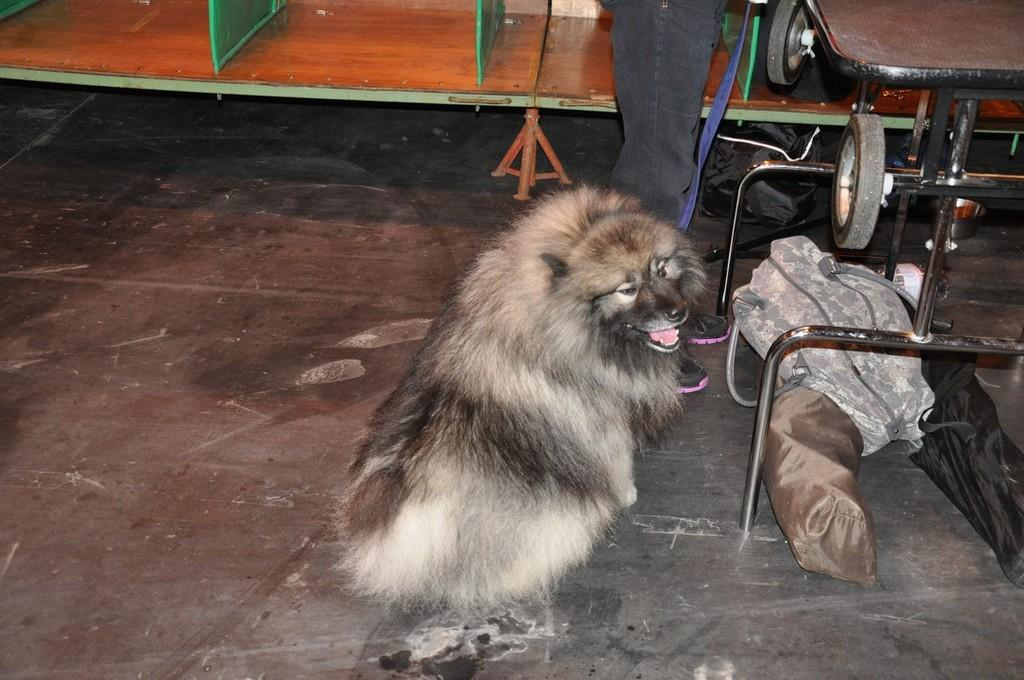What is located in the foreground of the image? In the foreground of the image, there is a dog, clothes, metal objects, wheels, and a person on the floor. What type of material is used for the objects in the foreground? The metal objects in the foreground are made of metal, and the clothes are likely made of fabric. What is the person on the floor doing? The person's actions are not clear from the image, but they are lying or sitting on the floor. What can be seen in the background of the image? In the background of the image, there are wooden objects. Can you describe the setting where the image was taken? The image may have been taken in a hall, based on the presence of wooden objects and the open space. How many robins are perched on the wooden objects in the background of the image? There are no robins present in the image; it features a dog, clothes, metal objects, wheels, and a person on the floor in the foreground, and wooden objects in the background. What color is the paint used on the shelf in the image? There is no shelf present in the image, so it is not possible to determine the color of any paint used on it. 